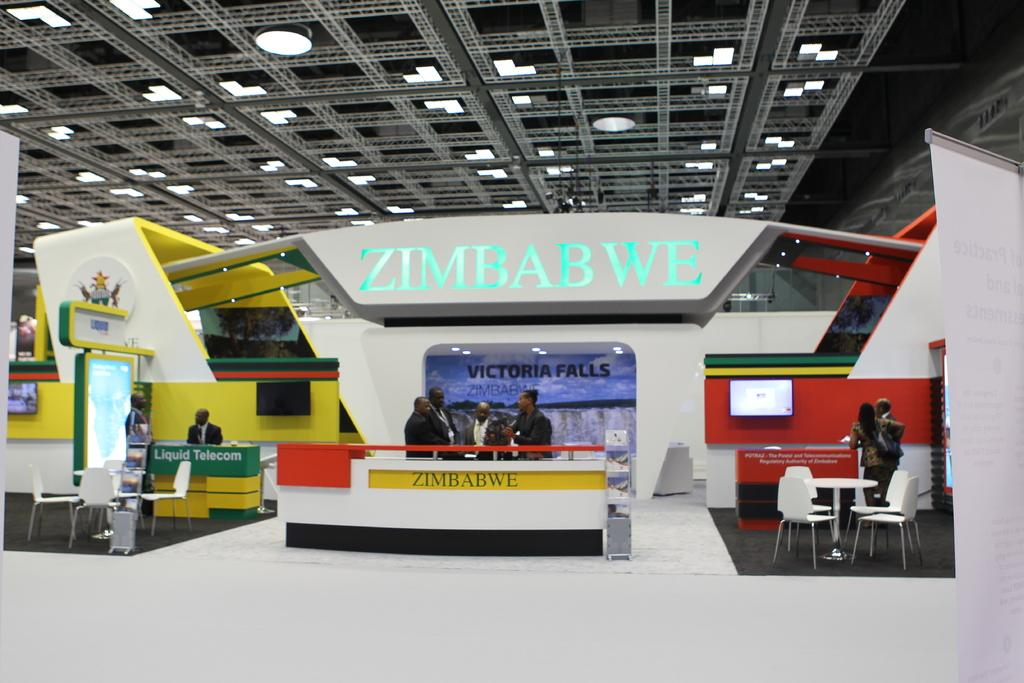What type of space is depicted in the image? The image shows an inner view of an office. Are there any people present in the office? Yes, there are people standing in the office. What is the position of the man in the office? There is a man seated in the office. What type of electronic device can be seen in the office? There is a television in the office. What type of furniture is present in the office? There are chairs and tables in the office. What type of lighting is present in the office? There are lights on the ceiling of the office. What type of bread is being toasted in the office? There is no bread or toaster present in the image; it shows an office with people, furniture, and a television. 